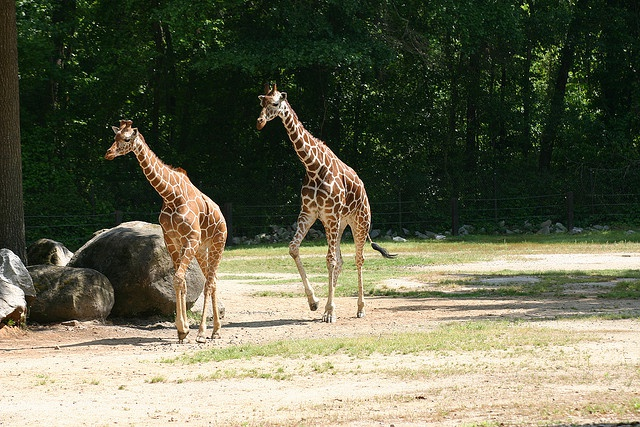Describe the objects in this image and their specific colors. I can see giraffe in black, ivory, maroon, and gray tones and giraffe in black, tan, maroon, gray, and ivory tones in this image. 